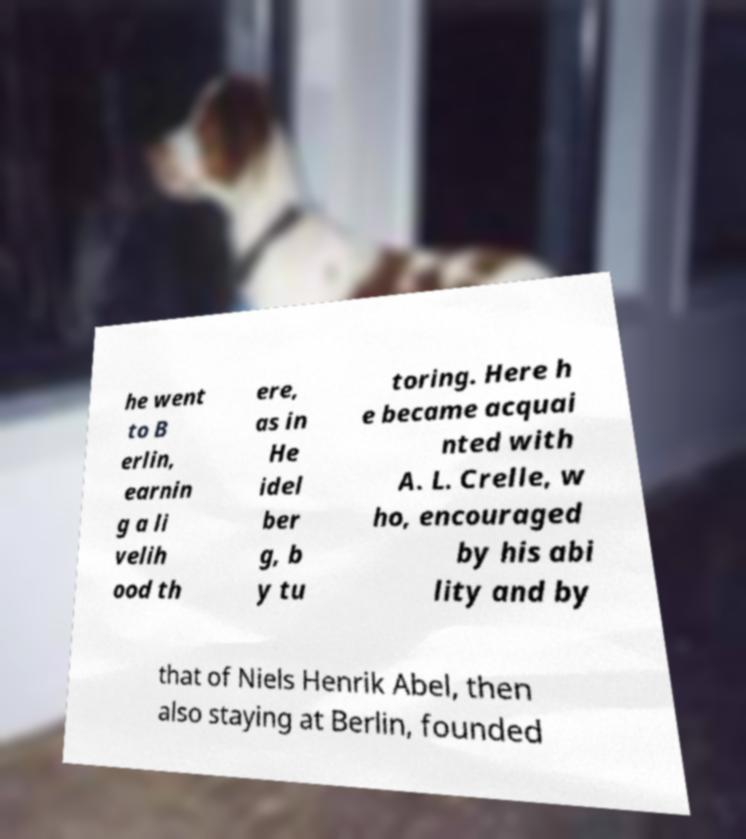I need the written content from this picture converted into text. Can you do that? he went to B erlin, earnin g a li velih ood th ere, as in He idel ber g, b y tu toring. Here h e became acquai nted with A. L. Crelle, w ho, encouraged by his abi lity and by that of Niels Henrik Abel, then also staying at Berlin, founded 